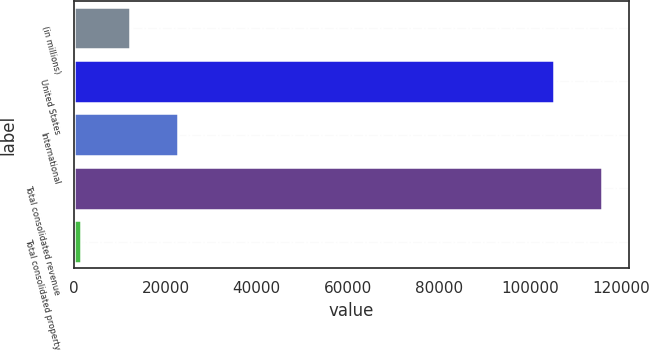Convert chart. <chart><loc_0><loc_0><loc_500><loc_500><bar_chart><fcel>(in millions)<fcel>United States<fcel>International<fcel>Total consolidated revenue<fcel>Total consolidated property<nl><fcel>12151.1<fcel>105205<fcel>22751.2<fcel>115805<fcel>1551<nl></chart> 